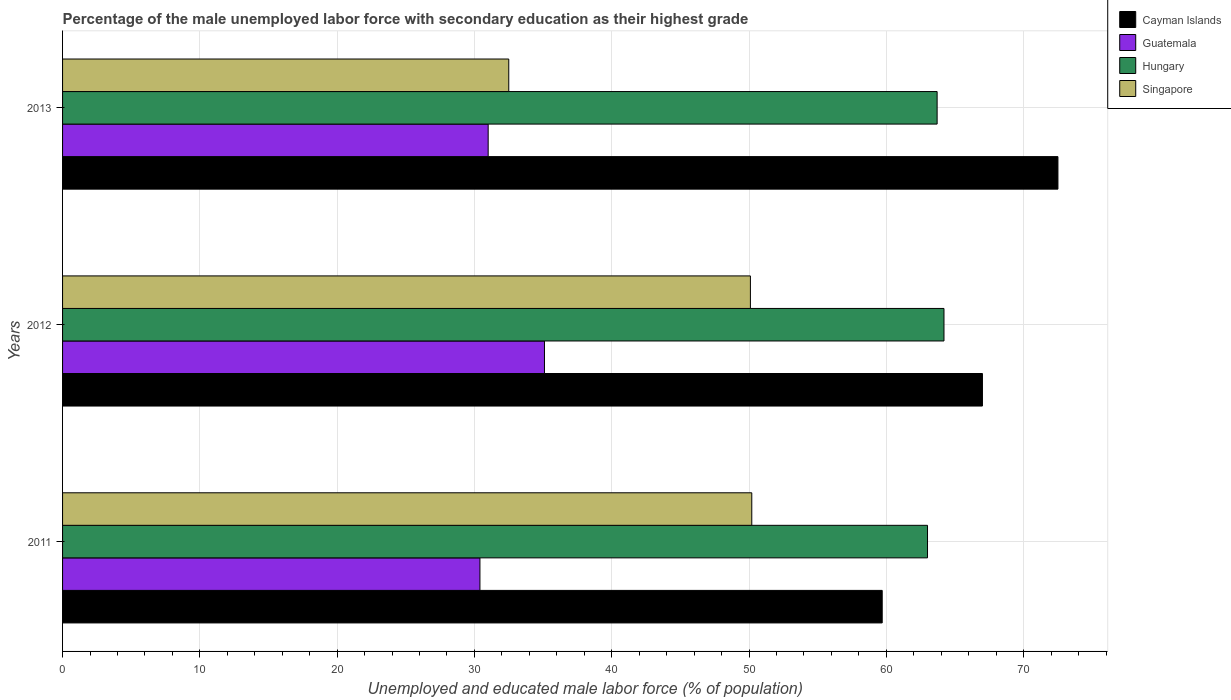Are the number of bars per tick equal to the number of legend labels?
Make the answer very short. Yes. Are the number of bars on each tick of the Y-axis equal?
Ensure brevity in your answer.  Yes. How many bars are there on the 2nd tick from the top?
Provide a short and direct response. 4. In how many cases, is the number of bars for a given year not equal to the number of legend labels?
Give a very brief answer. 0. What is the percentage of the unemployed male labor force with secondary education in Hungary in 2011?
Your response must be concise. 63. Across all years, what is the maximum percentage of the unemployed male labor force with secondary education in Cayman Islands?
Offer a terse response. 72.5. In which year was the percentage of the unemployed male labor force with secondary education in Guatemala maximum?
Keep it short and to the point. 2012. What is the total percentage of the unemployed male labor force with secondary education in Singapore in the graph?
Your answer should be compact. 132.8. What is the difference between the percentage of the unemployed male labor force with secondary education in Guatemala in 2011 and that in 2013?
Your answer should be very brief. -0.6. What is the difference between the percentage of the unemployed male labor force with secondary education in Cayman Islands in 2011 and the percentage of the unemployed male labor force with secondary education in Guatemala in 2013?
Give a very brief answer. 28.7. What is the average percentage of the unemployed male labor force with secondary education in Singapore per year?
Provide a short and direct response. 44.27. In the year 2013, what is the difference between the percentage of the unemployed male labor force with secondary education in Hungary and percentage of the unemployed male labor force with secondary education in Singapore?
Ensure brevity in your answer.  31.2. What is the ratio of the percentage of the unemployed male labor force with secondary education in Cayman Islands in 2011 to that in 2012?
Your response must be concise. 0.89. Is the difference between the percentage of the unemployed male labor force with secondary education in Hungary in 2012 and 2013 greater than the difference between the percentage of the unemployed male labor force with secondary education in Singapore in 2012 and 2013?
Your answer should be very brief. No. What is the difference between the highest and the second highest percentage of the unemployed male labor force with secondary education in Singapore?
Offer a terse response. 0.1. What is the difference between the highest and the lowest percentage of the unemployed male labor force with secondary education in Cayman Islands?
Your answer should be compact. 12.8. Is it the case that in every year, the sum of the percentage of the unemployed male labor force with secondary education in Hungary and percentage of the unemployed male labor force with secondary education in Guatemala is greater than the sum of percentage of the unemployed male labor force with secondary education in Cayman Islands and percentage of the unemployed male labor force with secondary education in Singapore?
Your answer should be compact. Yes. What does the 3rd bar from the top in 2011 represents?
Give a very brief answer. Guatemala. What does the 1st bar from the bottom in 2011 represents?
Make the answer very short. Cayman Islands. Is it the case that in every year, the sum of the percentage of the unemployed male labor force with secondary education in Singapore and percentage of the unemployed male labor force with secondary education in Hungary is greater than the percentage of the unemployed male labor force with secondary education in Guatemala?
Provide a short and direct response. Yes. How many bars are there?
Provide a short and direct response. 12. What is the difference between two consecutive major ticks on the X-axis?
Give a very brief answer. 10. Where does the legend appear in the graph?
Make the answer very short. Top right. How are the legend labels stacked?
Give a very brief answer. Vertical. What is the title of the graph?
Your response must be concise. Percentage of the male unemployed labor force with secondary education as their highest grade. Does "Croatia" appear as one of the legend labels in the graph?
Keep it short and to the point. No. What is the label or title of the X-axis?
Offer a very short reply. Unemployed and educated male labor force (% of population). What is the label or title of the Y-axis?
Ensure brevity in your answer.  Years. What is the Unemployed and educated male labor force (% of population) in Cayman Islands in 2011?
Give a very brief answer. 59.7. What is the Unemployed and educated male labor force (% of population) in Guatemala in 2011?
Give a very brief answer. 30.4. What is the Unemployed and educated male labor force (% of population) in Hungary in 2011?
Provide a succinct answer. 63. What is the Unemployed and educated male labor force (% of population) in Singapore in 2011?
Offer a very short reply. 50.2. What is the Unemployed and educated male labor force (% of population) in Cayman Islands in 2012?
Make the answer very short. 67. What is the Unemployed and educated male labor force (% of population) of Guatemala in 2012?
Your answer should be compact. 35.1. What is the Unemployed and educated male labor force (% of population) in Hungary in 2012?
Your response must be concise. 64.2. What is the Unemployed and educated male labor force (% of population) of Singapore in 2012?
Provide a short and direct response. 50.1. What is the Unemployed and educated male labor force (% of population) of Cayman Islands in 2013?
Provide a short and direct response. 72.5. What is the Unemployed and educated male labor force (% of population) of Hungary in 2013?
Offer a very short reply. 63.7. What is the Unemployed and educated male labor force (% of population) of Singapore in 2013?
Offer a terse response. 32.5. Across all years, what is the maximum Unemployed and educated male labor force (% of population) in Cayman Islands?
Make the answer very short. 72.5. Across all years, what is the maximum Unemployed and educated male labor force (% of population) in Guatemala?
Ensure brevity in your answer.  35.1. Across all years, what is the maximum Unemployed and educated male labor force (% of population) of Hungary?
Provide a succinct answer. 64.2. Across all years, what is the maximum Unemployed and educated male labor force (% of population) of Singapore?
Give a very brief answer. 50.2. Across all years, what is the minimum Unemployed and educated male labor force (% of population) of Cayman Islands?
Offer a terse response. 59.7. Across all years, what is the minimum Unemployed and educated male labor force (% of population) in Guatemala?
Ensure brevity in your answer.  30.4. Across all years, what is the minimum Unemployed and educated male labor force (% of population) in Singapore?
Provide a short and direct response. 32.5. What is the total Unemployed and educated male labor force (% of population) in Cayman Islands in the graph?
Provide a succinct answer. 199.2. What is the total Unemployed and educated male labor force (% of population) of Guatemala in the graph?
Your answer should be compact. 96.5. What is the total Unemployed and educated male labor force (% of population) of Hungary in the graph?
Your response must be concise. 190.9. What is the total Unemployed and educated male labor force (% of population) of Singapore in the graph?
Provide a succinct answer. 132.8. What is the difference between the Unemployed and educated male labor force (% of population) of Cayman Islands in 2011 and that in 2012?
Ensure brevity in your answer.  -7.3. What is the difference between the Unemployed and educated male labor force (% of population) of Cayman Islands in 2011 and the Unemployed and educated male labor force (% of population) of Guatemala in 2012?
Your answer should be very brief. 24.6. What is the difference between the Unemployed and educated male labor force (% of population) of Cayman Islands in 2011 and the Unemployed and educated male labor force (% of population) of Hungary in 2012?
Offer a very short reply. -4.5. What is the difference between the Unemployed and educated male labor force (% of population) in Cayman Islands in 2011 and the Unemployed and educated male labor force (% of population) in Singapore in 2012?
Make the answer very short. 9.6. What is the difference between the Unemployed and educated male labor force (% of population) in Guatemala in 2011 and the Unemployed and educated male labor force (% of population) in Hungary in 2012?
Offer a very short reply. -33.8. What is the difference between the Unemployed and educated male labor force (% of population) of Guatemala in 2011 and the Unemployed and educated male labor force (% of population) of Singapore in 2012?
Keep it short and to the point. -19.7. What is the difference between the Unemployed and educated male labor force (% of population) in Cayman Islands in 2011 and the Unemployed and educated male labor force (% of population) in Guatemala in 2013?
Your response must be concise. 28.7. What is the difference between the Unemployed and educated male labor force (% of population) in Cayman Islands in 2011 and the Unemployed and educated male labor force (% of population) in Hungary in 2013?
Give a very brief answer. -4. What is the difference between the Unemployed and educated male labor force (% of population) of Cayman Islands in 2011 and the Unemployed and educated male labor force (% of population) of Singapore in 2013?
Ensure brevity in your answer.  27.2. What is the difference between the Unemployed and educated male labor force (% of population) of Guatemala in 2011 and the Unemployed and educated male labor force (% of population) of Hungary in 2013?
Keep it short and to the point. -33.3. What is the difference between the Unemployed and educated male labor force (% of population) in Hungary in 2011 and the Unemployed and educated male labor force (% of population) in Singapore in 2013?
Give a very brief answer. 30.5. What is the difference between the Unemployed and educated male labor force (% of population) of Cayman Islands in 2012 and the Unemployed and educated male labor force (% of population) of Hungary in 2013?
Provide a succinct answer. 3.3. What is the difference between the Unemployed and educated male labor force (% of population) of Cayman Islands in 2012 and the Unemployed and educated male labor force (% of population) of Singapore in 2013?
Offer a very short reply. 34.5. What is the difference between the Unemployed and educated male labor force (% of population) in Guatemala in 2012 and the Unemployed and educated male labor force (% of population) in Hungary in 2013?
Your answer should be very brief. -28.6. What is the difference between the Unemployed and educated male labor force (% of population) in Guatemala in 2012 and the Unemployed and educated male labor force (% of population) in Singapore in 2013?
Offer a very short reply. 2.6. What is the difference between the Unemployed and educated male labor force (% of population) of Hungary in 2012 and the Unemployed and educated male labor force (% of population) of Singapore in 2013?
Your answer should be very brief. 31.7. What is the average Unemployed and educated male labor force (% of population) in Cayman Islands per year?
Ensure brevity in your answer.  66.4. What is the average Unemployed and educated male labor force (% of population) in Guatemala per year?
Provide a short and direct response. 32.17. What is the average Unemployed and educated male labor force (% of population) of Hungary per year?
Make the answer very short. 63.63. What is the average Unemployed and educated male labor force (% of population) in Singapore per year?
Keep it short and to the point. 44.27. In the year 2011, what is the difference between the Unemployed and educated male labor force (% of population) in Cayman Islands and Unemployed and educated male labor force (% of population) in Guatemala?
Your answer should be compact. 29.3. In the year 2011, what is the difference between the Unemployed and educated male labor force (% of population) of Cayman Islands and Unemployed and educated male labor force (% of population) of Hungary?
Offer a very short reply. -3.3. In the year 2011, what is the difference between the Unemployed and educated male labor force (% of population) of Guatemala and Unemployed and educated male labor force (% of population) of Hungary?
Ensure brevity in your answer.  -32.6. In the year 2011, what is the difference between the Unemployed and educated male labor force (% of population) in Guatemala and Unemployed and educated male labor force (% of population) in Singapore?
Your answer should be compact. -19.8. In the year 2012, what is the difference between the Unemployed and educated male labor force (% of population) in Cayman Islands and Unemployed and educated male labor force (% of population) in Guatemala?
Make the answer very short. 31.9. In the year 2012, what is the difference between the Unemployed and educated male labor force (% of population) of Guatemala and Unemployed and educated male labor force (% of population) of Hungary?
Your answer should be very brief. -29.1. In the year 2013, what is the difference between the Unemployed and educated male labor force (% of population) of Cayman Islands and Unemployed and educated male labor force (% of population) of Guatemala?
Ensure brevity in your answer.  41.5. In the year 2013, what is the difference between the Unemployed and educated male labor force (% of population) in Cayman Islands and Unemployed and educated male labor force (% of population) in Hungary?
Provide a short and direct response. 8.8. In the year 2013, what is the difference between the Unemployed and educated male labor force (% of population) of Guatemala and Unemployed and educated male labor force (% of population) of Hungary?
Ensure brevity in your answer.  -32.7. In the year 2013, what is the difference between the Unemployed and educated male labor force (% of population) in Hungary and Unemployed and educated male labor force (% of population) in Singapore?
Give a very brief answer. 31.2. What is the ratio of the Unemployed and educated male labor force (% of population) in Cayman Islands in 2011 to that in 2012?
Your answer should be compact. 0.89. What is the ratio of the Unemployed and educated male labor force (% of population) in Guatemala in 2011 to that in 2012?
Provide a short and direct response. 0.87. What is the ratio of the Unemployed and educated male labor force (% of population) of Hungary in 2011 to that in 2012?
Provide a succinct answer. 0.98. What is the ratio of the Unemployed and educated male labor force (% of population) in Cayman Islands in 2011 to that in 2013?
Keep it short and to the point. 0.82. What is the ratio of the Unemployed and educated male labor force (% of population) in Guatemala in 2011 to that in 2013?
Your response must be concise. 0.98. What is the ratio of the Unemployed and educated male labor force (% of population) of Hungary in 2011 to that in 2013?
Give a very brief answer. 0.99. What is the ratio of the Unemployed and educated male labor force (% of population) of Singapore in 2011 to that in 2013?
Make the answer very short. 1.54. What is the ratio of the Unemployed and educated male labor force (% of population) of Cayman Islands in 2012 to that in 2013?
Provide a short and direct response. 0.92. What is the ratio of the Unemployed and educated male labor force (% of population) of Guatemala in 2012 to that in 2013?
Your response must be concise. 1.13. What is the ratio of the Unemployed and educated male labor force (% of population) in Hungary in 2012 to that in 2013?
Offer a terse response. 1.01. What is the ratio of the Unemployed and educated male labor force (% of population) of Singapore in 2012 to that in 2013?
Offer a very short reply. 1.54. What is the difference between the highest and the second highest Unemployed and educated male labor force (% of population) of Hungary?
Offer a very short reply. 0.5. What is the difference between the highest and the lowest Unemployed and educated male labor force (% of population) in Cayman Islands?
Keep it short and to the point. 12.8. What is the difference between the highest and the lowest Unemployed and educated male labor force (% of population) of Guatemala?
Offer a terse response. 4.7. 